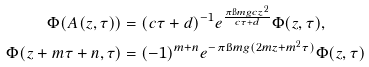<formula> <loc_0><loc_0><loc_500><loc_500>\Phi ( A ( z , \tau ) ) & = ( c \tau + d ) ^ { - 1 } e ^ { \frac { \pi \i m g c z ^ { 2 } } { c \tau + d } } \Phi ( z , \tau ) , \\ \Phi ( z + m \tau + n , \tau ) & = ( - 1 ) ^ { m + n } e ^ { - \pi \i m g ( 2 m z + m ^ { 2 } \tau ) } \Phi ( z , \tau )</formula> 